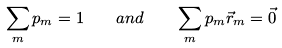<formula> <loc_0><loc_0><loc_500><loc_500>\sum _ { m } p _ { m } = 1 \quad a n d \quad \sum _ { m } p _ { m } \vec { r } _ { m } = \vec { 0 }</formula> 